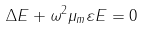Convert formula to latex. <formula><loc_0><loc_0><loc_500><loc_500>\Delta E + \omega ^ { 2 } \mu _ { m } \varepsilon E = 0</formula> 